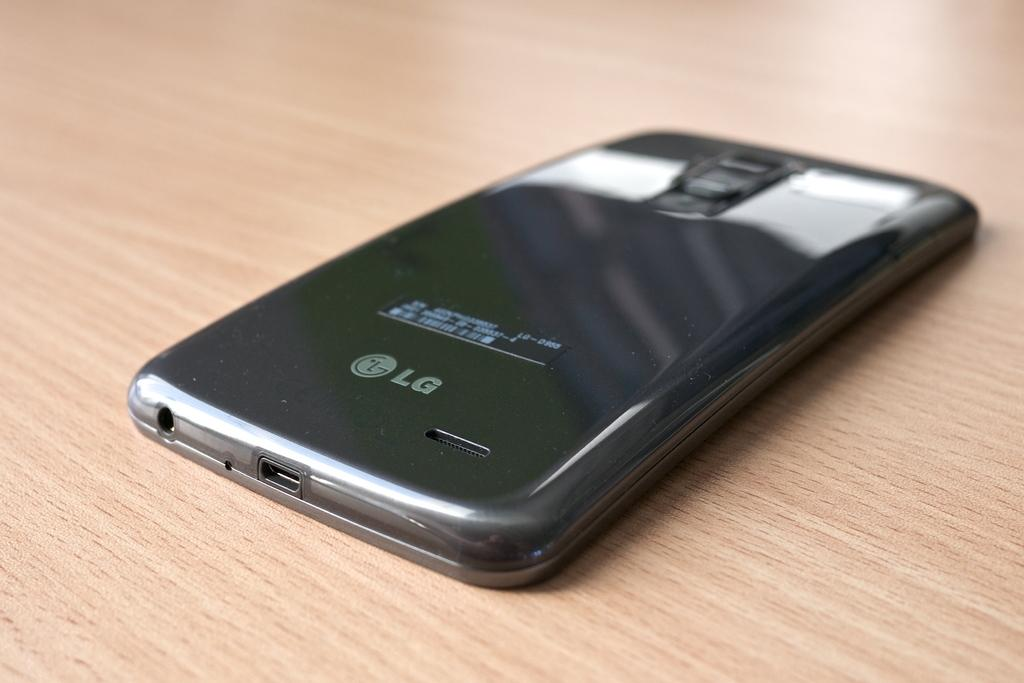<image>
Give a short and clear explanation of the subsequent image. a phone that had the word LG on it 